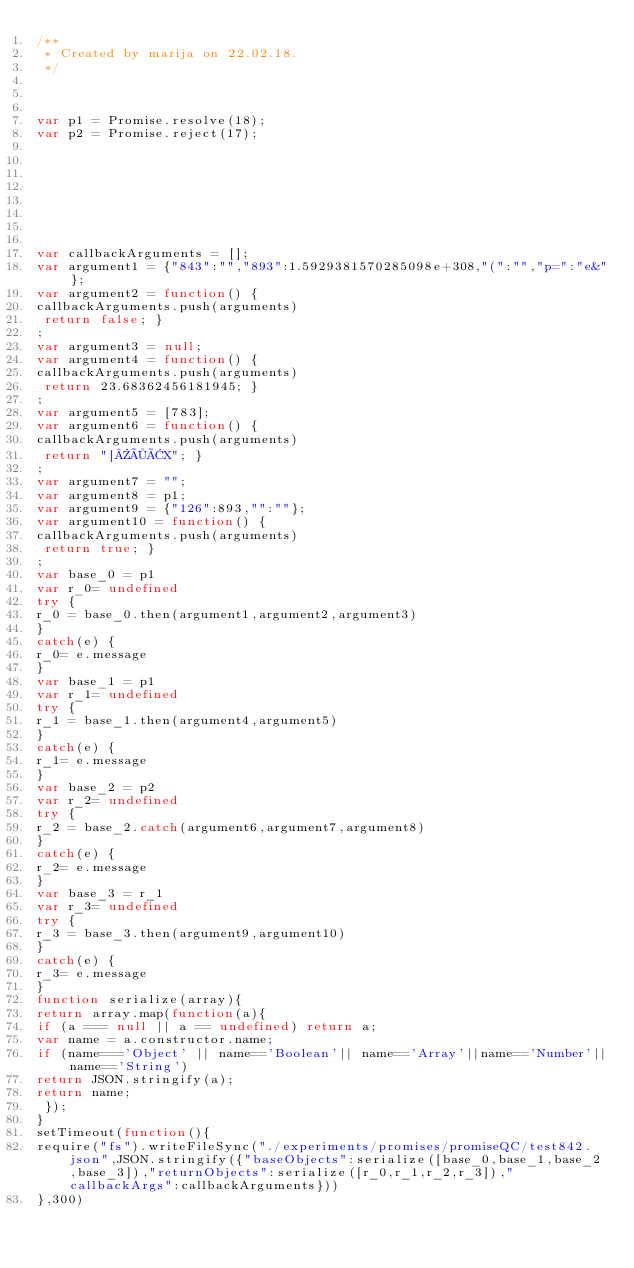Convert code to text. <code><loc_0><loc_0><loc_500><loc_500><_JavaScript_>/**
 * Created by marija on 22.02.18.
 */



var p1 = Promise.resolve(18);
var p2 = Promise.reject(17);








var callbackArguments = [];
var argument1 = {"843":"","893":1.5929381570285098e+308,"(":"","p=":"e&"};
var argument2 = function() {
callbackArguments.push(arguments)
 return false; }
;
var argument3 = null;
var argument4 = function() {
callbackArguments.push(arguments)
 return 23.68362456181945; }
;
var argument5 = [783];
var argument6 = function() {
callbackArguments.push(arguments)
 return "[×ÂX"; }
;
var argument7 = "";
var argument8 = p1;
var argument9 = {"126":893,"":""};
var argument10 = function() {
callbackArguments.push(arguments)
 return true; }
;
var base_0 = p1
var r_0= undefined
try {
r_0 = base_0.then(argument1,argument2,argument3)
}
catch(e) {
r_0= e.message
}
var base_1 = p1
var r_1= undefined
try {
r_1 = base_1.then(argument4,argument5)
}
catch(e) {
r_1= e.message
}
var base_2 = p2
var r_2= undefined
try {
r_2 = base_2.catch(argument6,argument7,argument8)
}
catch(e) {
r_2= e.message
}
var base_3 = r_1
var r_3= undefined
try {
r_3 = base_3.then(argument9,argument10)
}
catch(e) {
r_3= e.message
}
function serialize(array){
return array.map(function(a){
if (a === null || a == undefined) return a;
var name = a.constructor.name;
if (name==='Object' || name=='Boolean'|| name=='Array'||name=='Number'||name=='String')
return JSON.stringify(a);
return name;
 });
}
setTimeout(function(){
require("fs").writeFileSync("./experiments/promises/promiseQC/test842.json",JSON.stringify({"baseObjects":serialize([base_0,base_1,base_2,base_3]),"returnObjects":serialize([r_0,r_1,r_2,r_3]),"callbackArgs":callbackArguments}))
},300)</code> 